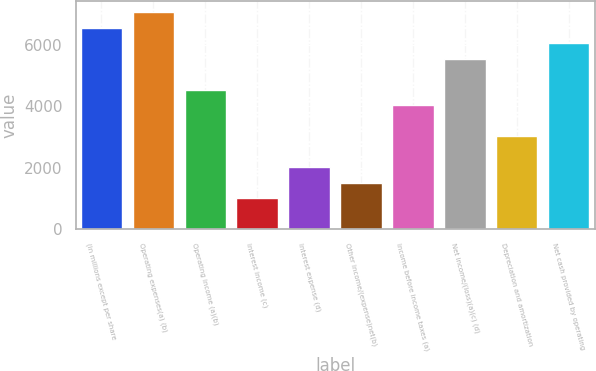<chart> <loc_0><loc_0><loc_500><loc_500><bar_chart><fcel>(in millions except per share<fcel>Operating expenses(a) (b)<fcel>Operating income (a)(b)<fcel>Interest income (c)<fcel>Interest expense (d)<fcel>Other income/(expense)net(b)<fcel>Income before income taxes (a)<fcel>Net income/(loss)(a)(c) (d)<fcel>Depreciation and amortization<fcel>Net cash provided by operating<nl><fcel>6562.84<fcel>7067.62<fcel>4543.72<fcel>1010.26<fcel>2019.82<fcel>1515.04<fcel>4038.94<fcel>5553.28<fcel>3029.38<fcel>6058.06<nl></chart> 